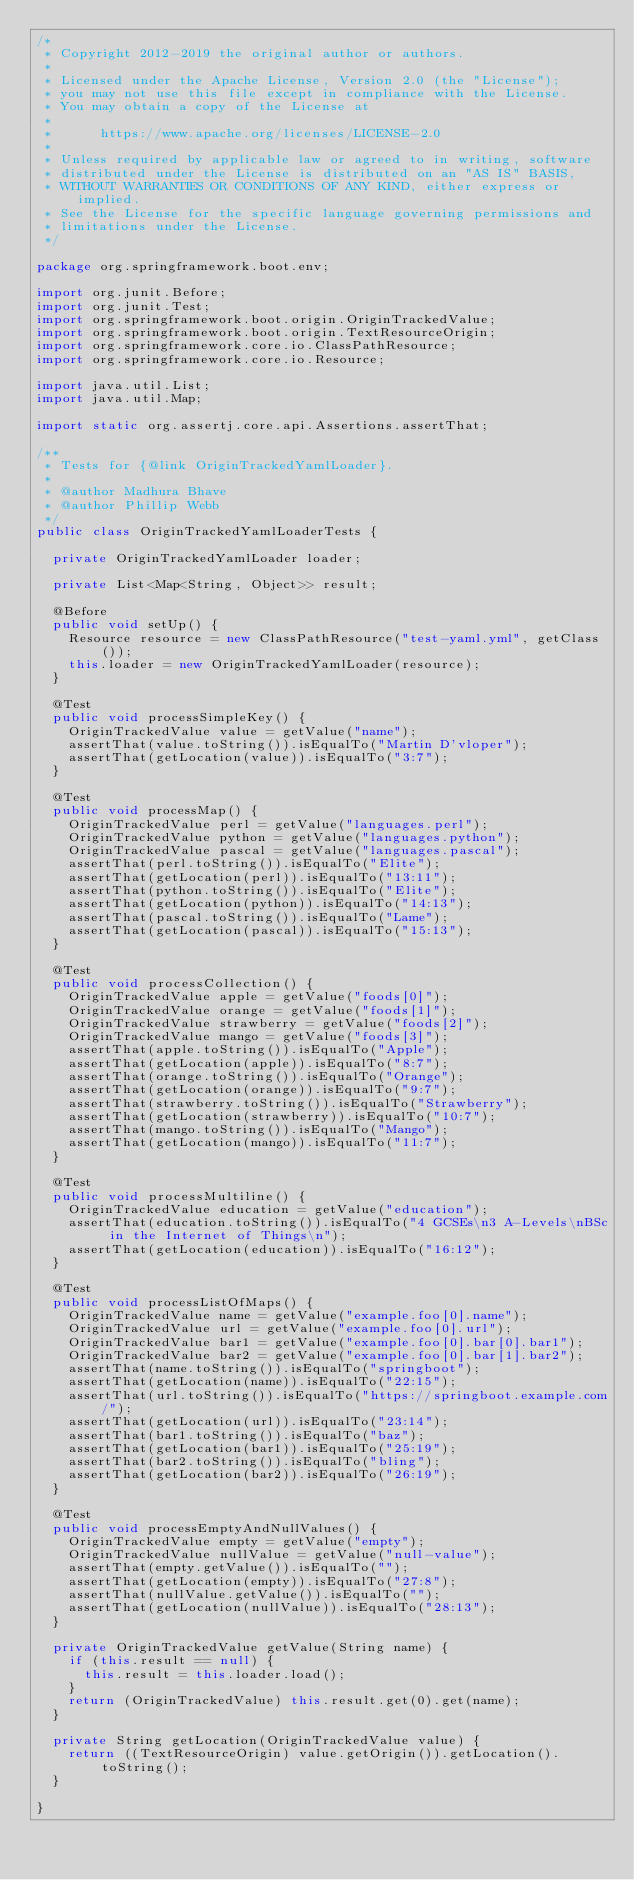Convert code to text. <code><loc_0><loc_0><loc_500><loc_500><_Java_>/*
 * Copyright 2012-2019 the original author or authors.
 *
 * Licensed under the Apache License, Version 2.0 (the "License");
 * you may not use this file except in compliance with the License.
 * You may obtain a copy of the License at
 *
 *      https://www.apache.org/licenses/LICENSE-2.0
 *
 * Unless required by applicable law or agreed to in writing, software
 * distributed under the License is distributed on an "AS IS" BASIS,
 * WITHOUT WARRANTIES OR CONDITIONS OF ANY KIND, either express or implied.
 * See the License for the specific language governing permissions and
 * limitations under the License.
 */

package org.springframework.boot.env;

import org.junit.Before;
import org.junit.Test;
import org.springframework.boot.origin.OriginTrackedValue;
import org.springframework.boot.origin.TextResourceOrigin;
import org.springframework.core.io.ClassPathResource;
import org.springframework.core.io.Resource;

import java.util.List;
import java.util.Map;

import static org.assertj.core.api.Assertions.assertThat;

/**
 * Tests for {@link OriginTrackedYamlLoader}.
 *
 * @author Madhura Bhave
 * @author Phillip Webb
 */
public class OriginTrackedYamlLoaderTests {

	private OriginTrackedYamlLoader loader;

	private List<Map<String, Object>> result;

	@Before
	public void setUp() {
		Resource resource = new ClassPathResource("test-yaml.yml", getClass());
		this.loader = new OriginTrackedYamlLoader(resource);
	}

	@Test
	public void processSimpleKey() {
		OriginTrackedValue value = getValue("name");
		assertThat(value.toString()).isEqualTo("Martin D'vloper");
		assertThat(getLocation(value)).isEqualTo("3:7");
	}

	@Test
	public void processMap() {
		OriginTrackedValue perl = getValue("languages.perl");
		OriginTrackedValue python = getValue("languages.python");
		OriginTrackedValue pascal = getValue("languages.pascal");
		assertThat(perl.toString()).isEqualTo("Elite");
		assertThat(getLocation(perl)).isEqualTo("13:11");
		assertThat(python.toString()).isEqualTo("Elite");
		assertThat(getLocation(python)).isEqualTo("14:13");
		assertThat(pascal.toString()).isEqualTo("Lame");
		assertThat(getLocation(pascal)).isEqualTo("15:13");
	}

	@Test
	public void processCollection() {
		OriginTrackedValue apple = getValue("foods[0]");
		OriginTrackedValue orange = getValue("foods[1]");
		OriginTrackedValue strawberry = getValue("foods[2]");
		OriginTrackedValue mango = getValue("foods[3]");
		assertThat(apple.toString()).isEqualTo("Apple");
		assertThat(getLocation(apple)).isEqualTo("8:7");
		assertThat(orange.toString()).isEqualTo("Orange");
		assertThat(getLocation(orange)).isEqualTo("9:7");
		assertThat(strawberry.toString()).isEqualTo("Strawberry");
		assertThat(getLocation(strawberry)).isEqualTo("10:7");
		assertThat(mango.toString()).isEqualTo("Mango");
		assertThat(getLocation(mango)).isEqualTo("11:7");
	}

	@Test
	public void processMultiline() {
		OriginTrackedValue education = getValue("education");
		assertThat(education.toString()).isEqualTo("4 GCSEs\n3 A-Levels\nBSc in the Internet of Things\n");
		assertThat(getLocation(education)).isEqualTo("16:12");
	}

	@Test
	public void processListOfMaps() {
		OriginTrackedValue name = getValue("example.foo[0].name");
		OriginTrackedValue url = getValue("example.foo[0].url");
		OriginTrackedValue bar1 = getValue("example.foo[0].bar[0].bar1");
		OriginTrackedValue bar2 = getValue("example.foo[0].bar[1].bar2");
		assertThat(name.toString()).isEqualTo("springboot");
		assertThat(getLocation(name)).isEqualTo("22:15");
		assertThat(url.toString()).isEqualTo("https://springboot.example.com/");
		assertThat(getLocation(url)).isEqualTo("23:14");
		assertThat(bar1.toString()).isEqualTo("baz");
		assertThat(getLocation(bar1)).isEqualTo("25:19");
		assertThat(bar2.toString()).isEqualTo("bling");
		assertThat(getLocation(bar2)).isEqualTo("26:19");
	}

	@Test
	public void processEmptyAndNullValues() {
		OriginTrackedValue empty = getValue("empty");
		OriginTrackedValue nullValue = getValue("null-value");
		assertThat(empty.getValue()).isEqualTo("");
		assertThat(getLocation(empty)).isEqualTo("27:8");
		assertThat(nullValue.getValue()).isEqualTo("");
		assertThat(getLocation(nullValue)).isEqualTo("28:13");
	}

	private OriginTrackedValue getValue(String name) {
		if (this.result == null) {
			this.result = this.loader.load();
		}
		return (OriginTrackedValue) this.result.get(0).get(name);
	}

	private String getLocation(OriginTrackedValue value) {
		return ((TextResourceOrigin) value.getOrigin()).getLocation().toString();
	}

}
</code> 